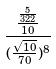<formula> <loc_0><loc_0><loc_500><loc_500>\frac { \frac { \frac { 5 } { 3 2 2 } } { 1 0 } } { ( \frac { \sqrt { 1 0 } } { 7 0 } ) ^ { 8 } }</formula> 